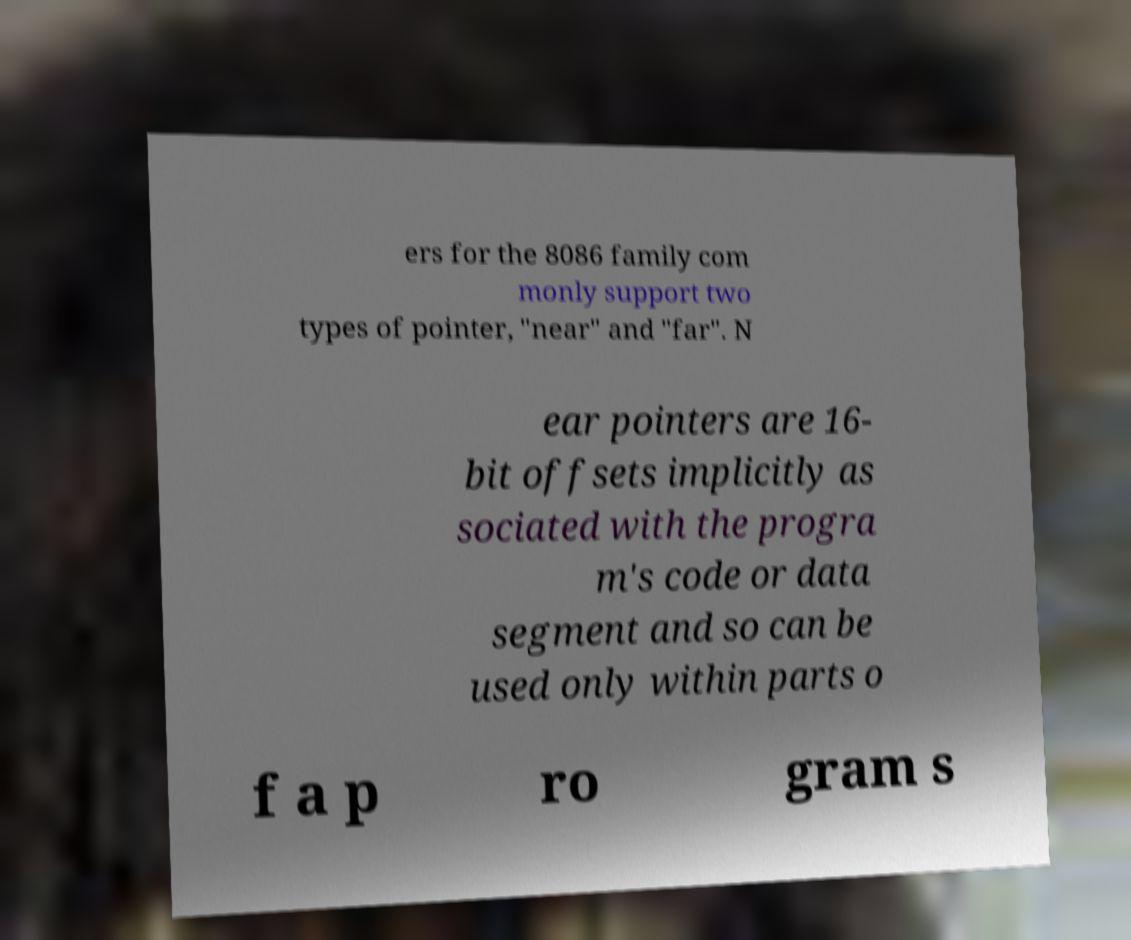For documentation purposes, I need the text within this image transcribed. Could you provide that? ers for the 8086 family com monly support two types of pointer, "near" and "far". N ear pointers are 16- bit offsets implicitly as sociated with the progra m's code or data segment and so can be used only within parts o f a p ro gram s 